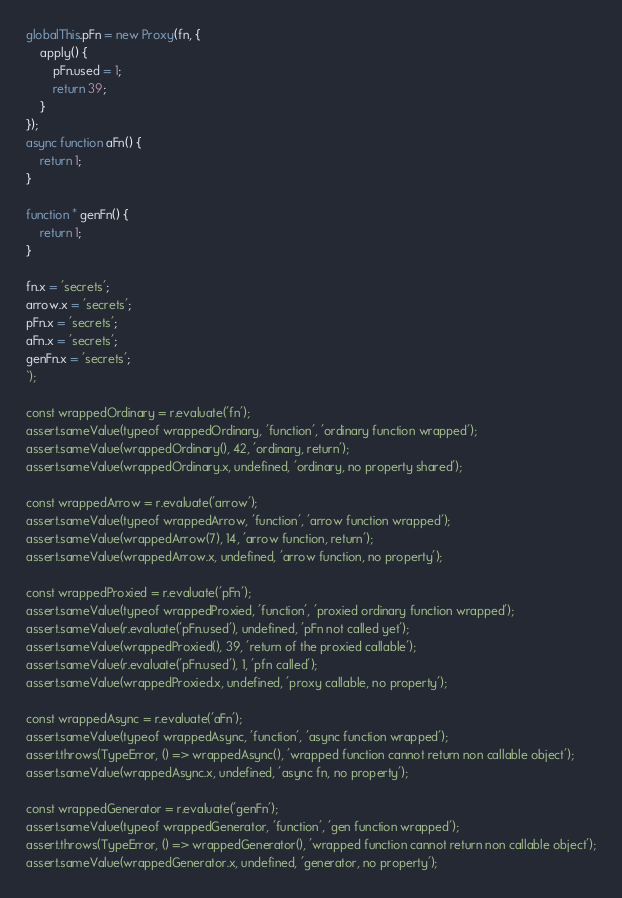<code> <loc_0><loc_0><loc_500><loc_500><_JavaScript_>globalThis.pFn = new Proxy(fn, {
    apply() {
        pFn.used = 1;
        return 39;
    }
});
async function aFn() {
    return 1;
}

function * genFn() {
    return 1;
}

fn.x = 'secrets';
arrow.x = 'secrets';
pFn.x = 'secrets';
aFn.x = 'secrets';
genFn.x = 'secrets';
`);

const wrappedOrdinary = r.evaluate('fn');
assert.sameValue(typeof wrappedOrdinary, 'function', 'ordinary function wrapped');
assert.sameValue(wrappedOrdinary(), 42, 'ordinary, return');
assert.sameValue(wrappedOrdinary.x, undefined, 'ordinary, no property shared');

const wrappedArrow = r.evaluate('arrow');
assert.sameValue(typeof wrappedArrow, 'function', 'arrow function wrapped');
assert.sameValue(wrappedArrow(7), 14, 'arrow function, return');
assert.sameValue(wrappedArrow.x, undefined, 'arrow function, no property');

const wrappedProxied = r.evaluate('pFn');
assert.sameValue(typeof wrappedProxied, 'function', 'proxied ordinary function wrapped');
assert.sameValue(r.evaluate('pFn.used'), undefined, 'pFn not called yet');
assert.sameValue(wrappedProxied(), 39, 'return of the proxied callable');
assert.sameValue(r.evaluate('pFn.used'), 1, 'pfn called');
assert.sameValue(wrappedProxied.x, undefined, 'proxy callable, no property');

const wrappedAsync = r.evaluate('aFn');
assert.sameValue(typeof wrappedAsync, 'function', 'async function wrapped');
assert.throws(TypeError, () => wrappedAsync(), 'wrapped function cannot return non callable object');
assert.sameValue(wrappedAsync.x, undefined, 'async fn, no property');

const wrappedGenerator = r.evaluate('genFn');
assert.sameValue(typeof wrappedGenerator, 'function', 'gen function wrapped');
assert.throws(TypeError, () => wrappedGenerator(), 'wrapped function cannot return non callable object');
assert.sameValue(wrappedGenerator.x, undefined, 'generator, no property');
</code> 